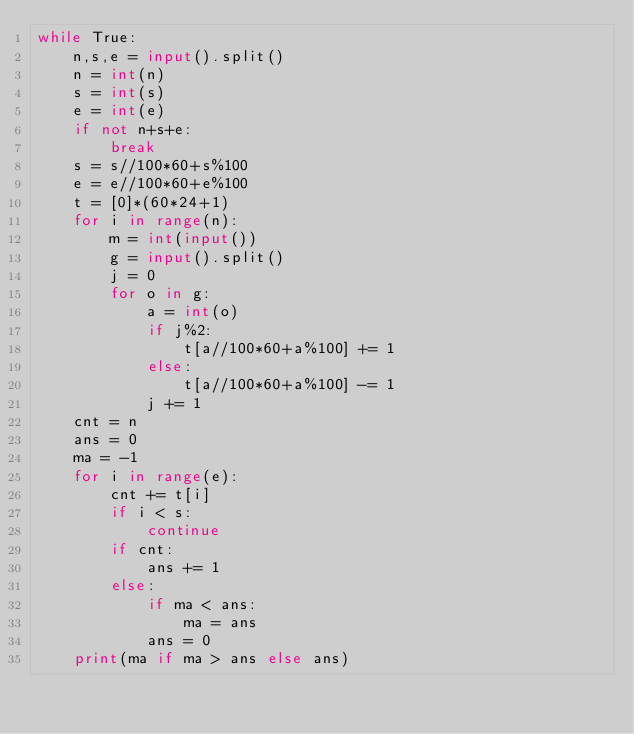<code> <loc_0><loc_0><loc_500><loc_500><_Python_>while True:
    n,s,e = input().split()
    n = int(n)
    s = int(s)
    e = int(e)
    if not n+s+e:
        break
    s = s//100*60+s%100
    e = e//100*60+e%100
    t = [0]*(60*24+1)
    for i in range(n):
        m = int(input())
        g = input().split()
        j = 0
        for o in g:
            a = int(o)
            if j%2:
                t[a//100*60+a%100] += 1
            else:
                t[a//100*60+a%100] -= 1
            j += 1
    cnt = n
    ans = 0
    ma = -1
    for i in range(e):
        cnt += t[i]
        if i < s:
            continue
        if cnt:
            ans += 1
        else:
            if ma < ans:
                ma = ans
            ans = 0
    print(ma if ma > ans else ans)</code> 